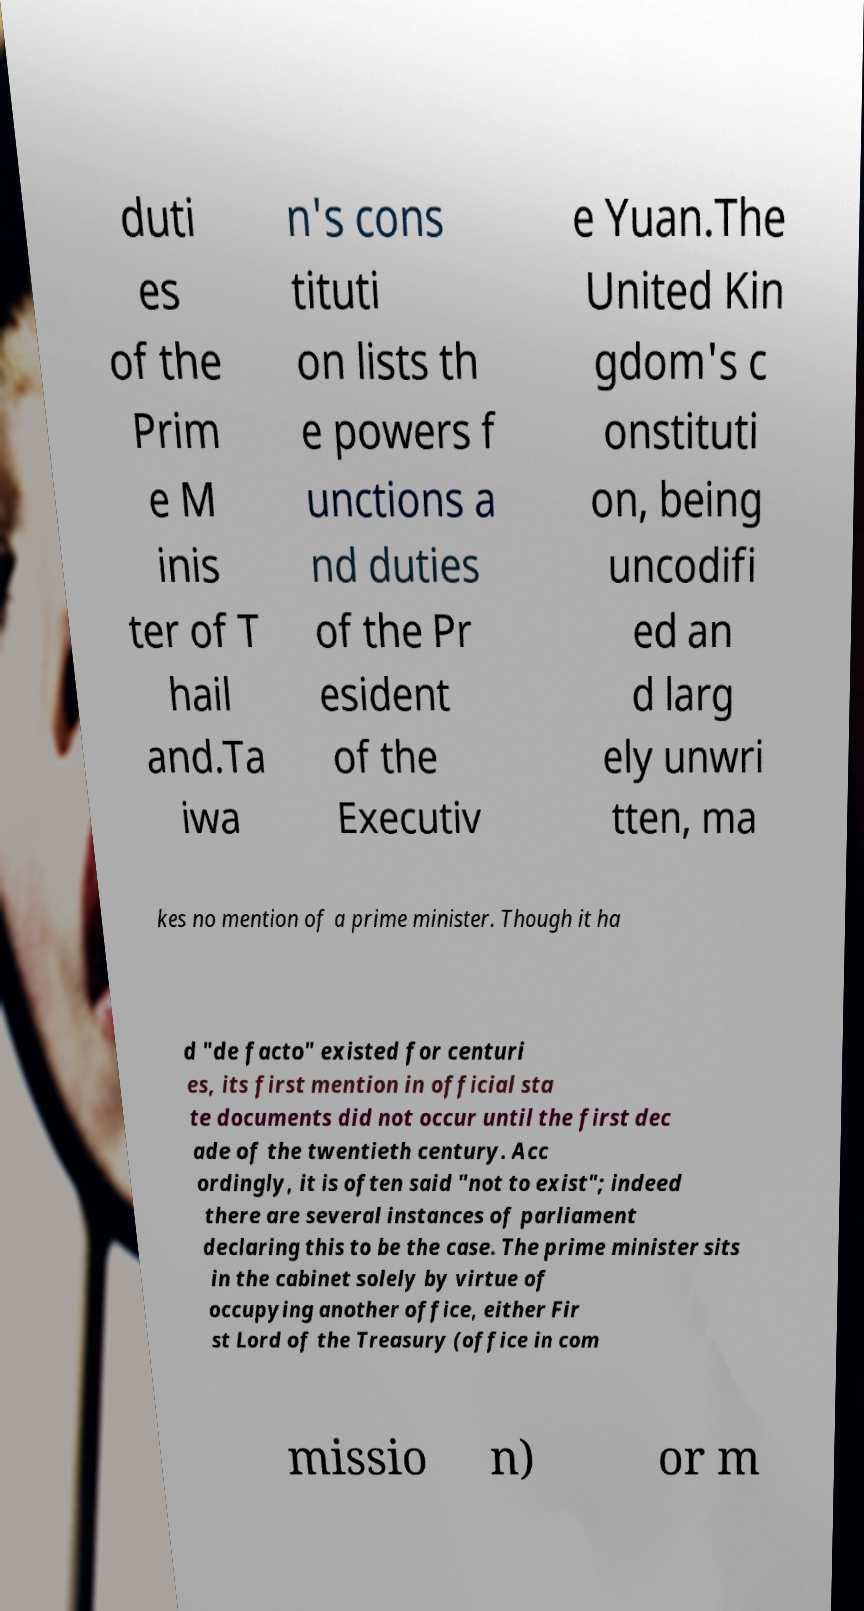For documentation purposes, I need the text within this image transcribed. Could you provide that? duti es of the Prim e M inis ter of T hail and.Ta iwa n's cons tituti on lists th e powers f unctions a nd duties of the Pr esident of the Executiv e Yuan.The United Kin gdom's c onstituti on, being uncodifi ed an d larg ely unwri tten, ma kes no mention of a prime minister. Though it ha d "de facto" existed for centuri es, its first mention in official sta te documents did not occur until the first dec ade of the twentieth century. Acc ordingly, it is often said "not to exist"; indeed there are several instances of parliament declaring this to be the case. The prime minister sits in the cabinet solely by virtue of occupying another office, either Fir st Lord of the Treasury (office in com missio n) or m 